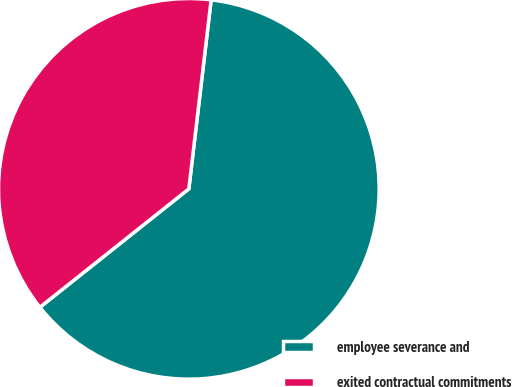Convert chart. <chart><loc_0><loc_0><loc_500><loc_500><pie_chart><fcel>employee severance and<fcel>exited contractual commitments<nl><fcel>62.44%<fcel>37.56%<nl></chart> 